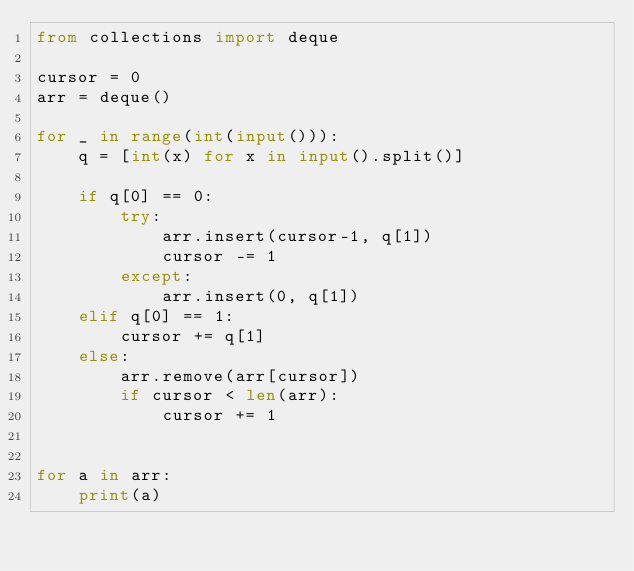Convert code to text. <code><loc_0><loc_0><loc_500><loc_500><_Python_>from collections import deque

cursor = 0
arr = deque()

for _ in range(int(input())):
    q = [int(x) for x in input().split()]

    if q[0] == 0:
        try:
            arr.insert(cursor-1, q[1])
            cursor -= 1
        except:
            arr.insert(0, q[1])
    elif q[0] == 1:
        cursor += q[1]
    else:
        arr.remove(arr[cursor])
        if cursor < len(arr):
            cursor += 1


for a in arr:
    print(a)

</code> 